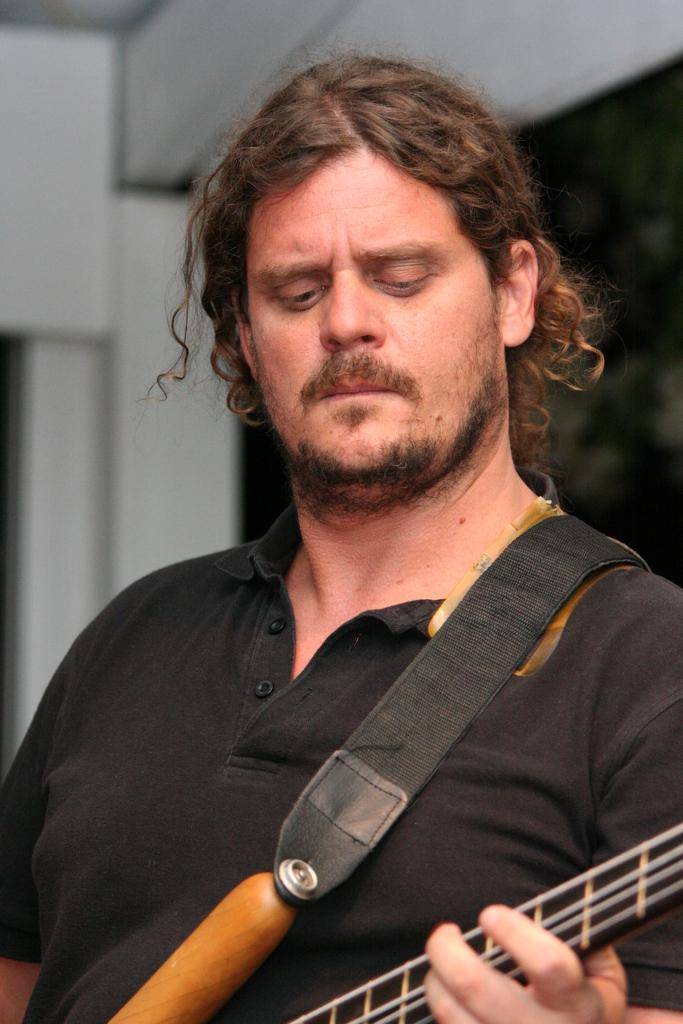What is the man in the image holding? The man is holding a musical instrument. What is the man wearing in the image? The man is wearing a black T-shirt. Can you describe the man's hair in the image? The man has long hair. What can be seen in the background of the image? There is a wall in the background of the image. What type of sock is the man wearing in the image? The image does not show the man's socks, so it cannot be determined what type of sock he is wearing. 